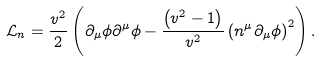Convert formula to latex. <formula><loc_0><loc_0><loc_500><loc_500>\mathcal { L } _ { n } = \frac { v ^ { 2 } } { 2 } \left ( \partial _ { \mu } \phi \partial ^ { \mu } \phi - \frac { \left ( v ^ { 2 } - 1 \right ) } { v ^ { 2 } } \left ( n ^ { \mu } \partial _ { \mu } \phi \right ) ^ { 2 } \right ) .</formula> 